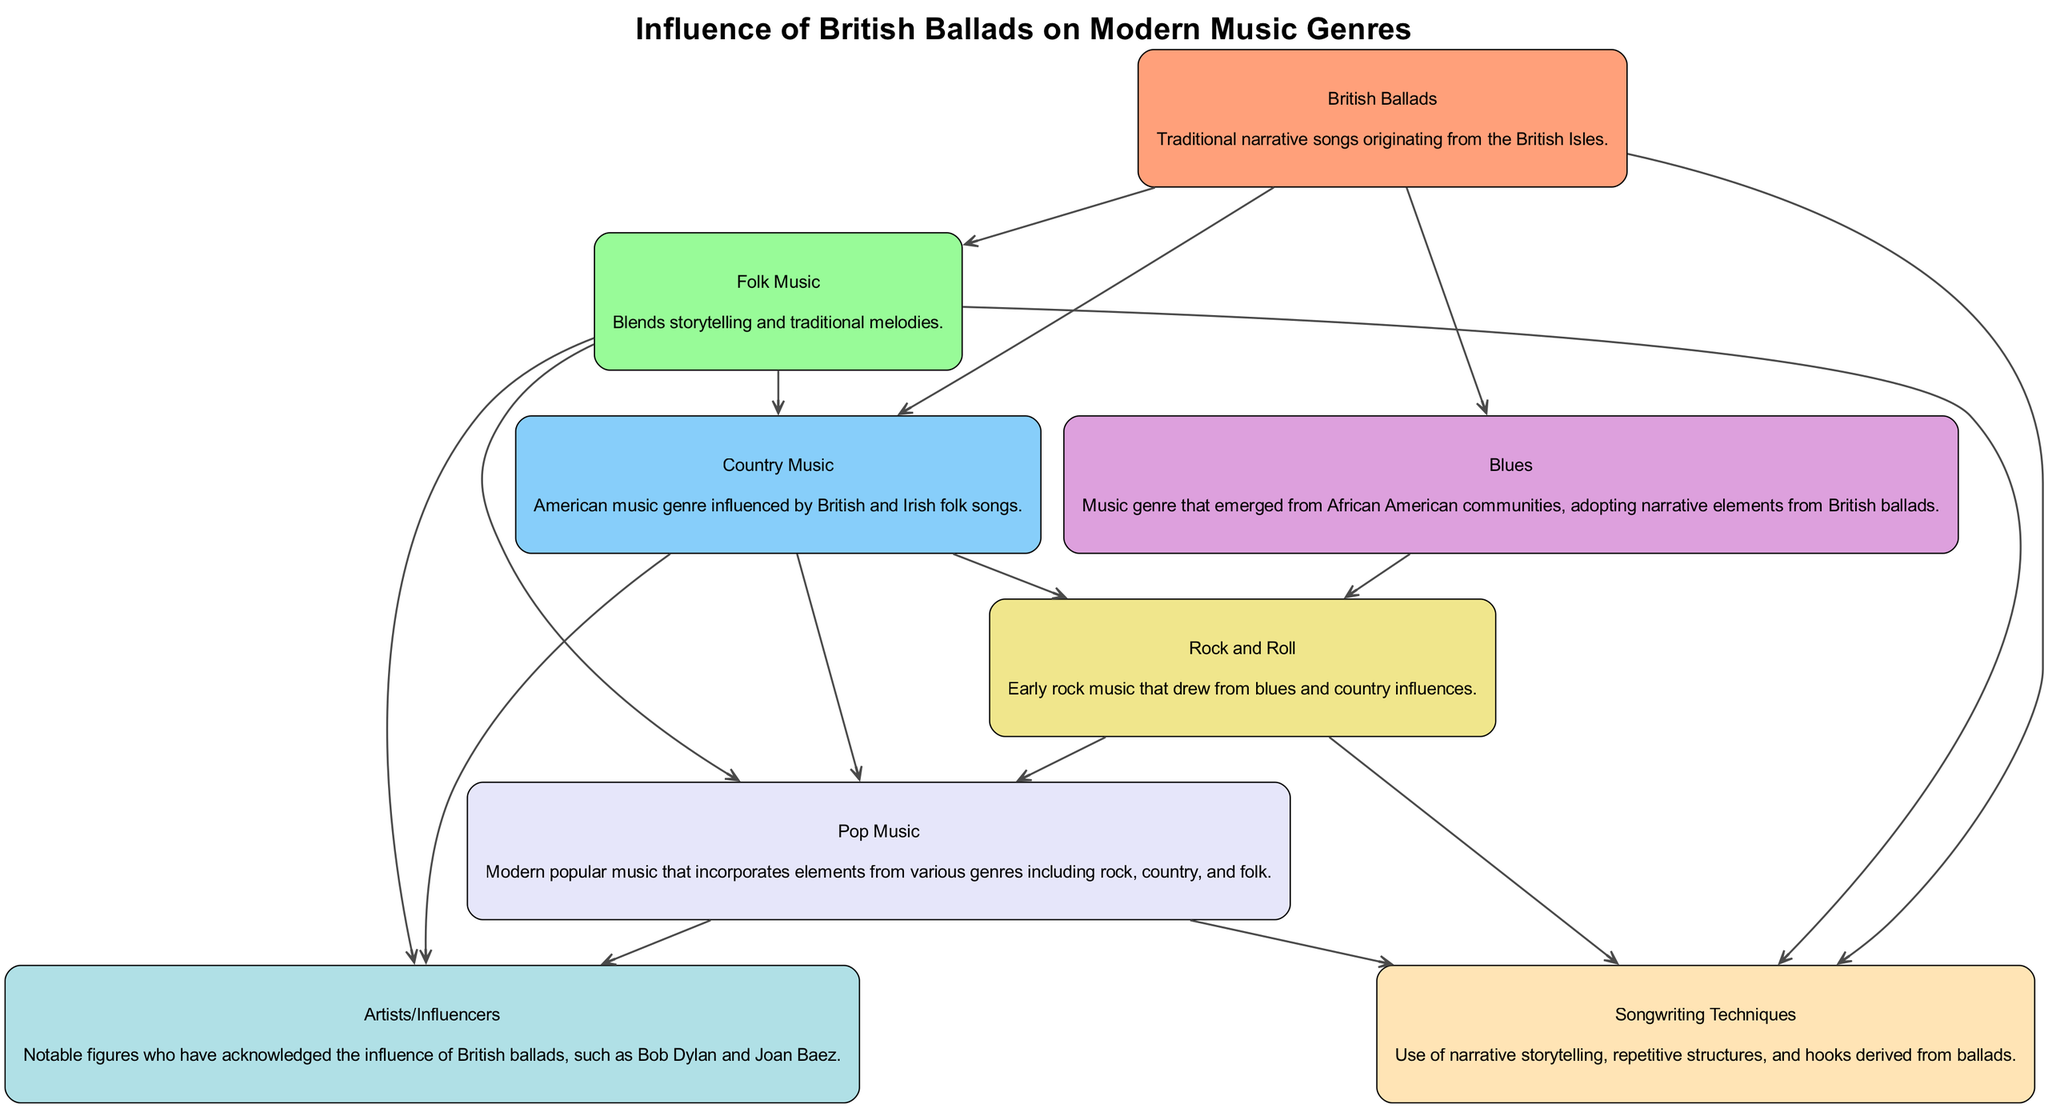What is the first block in the diagram? The first block is identified by "1" and contains the label "British Ballads". This is confirmed by the way the blocks are arranged and listed in the diagram’s data.
Answer: British Ballads How many blocks are related to "Folk Music"? "Folk Music" is related to "British Ballads", and it directly links to one block. This is deduced from the 'related_to' attribute of the block labeled "2".
Answer: 1 Which block is influenced by both "Country Music" and "Blues"? The block labeled "Rock and Roll" is influenced by both "Country Music" and "Blues", as indicated by the connections listed under the 'related_to' attribute in block "5".
Answer: Rock and Roll How many total blocks are represented in the diagram? There are eight blocks represented in the diagram, which can be confirmed by counting the blocks listed in the provided data.
Answer: 8 What color is used for the block labeled "Pop Music"? The block labeled "Pop Music" is assigned the fifth color from the custom palette. Since there are eight colors listed in the diagram, the specific color can be identified by its order in the palette.
Answer: #F0E68C Which artists or influences are mentioned in relation to "Pop Music"? The block labeled "Artists/Influencers" is related to "Pop Music", indicating that both are connected. The notable figures mentioned include Bob Dylan and Joan Baez.
Answer: Bob Dylan and Joan Baez Which block does "Songwriting Techniques" relate to? "Songwriting Techniques" relates to "British Ballads", "Folk Music", "Rock and Roll", and "Pop Music" as stated in its 'related_to' attribute. This indicates it draws influences from all these blocks.
Answer: British Ballads, Folk Music, Rock and Roll, Pop Music What is the dominant influence on "Country Music"? The dominant influence on "Country Music" is "British Ballads" as indicated in its 'related_to' list within block "3". This illustrates how traditional forms have shaped modern genres.
Answer: British Ballads 